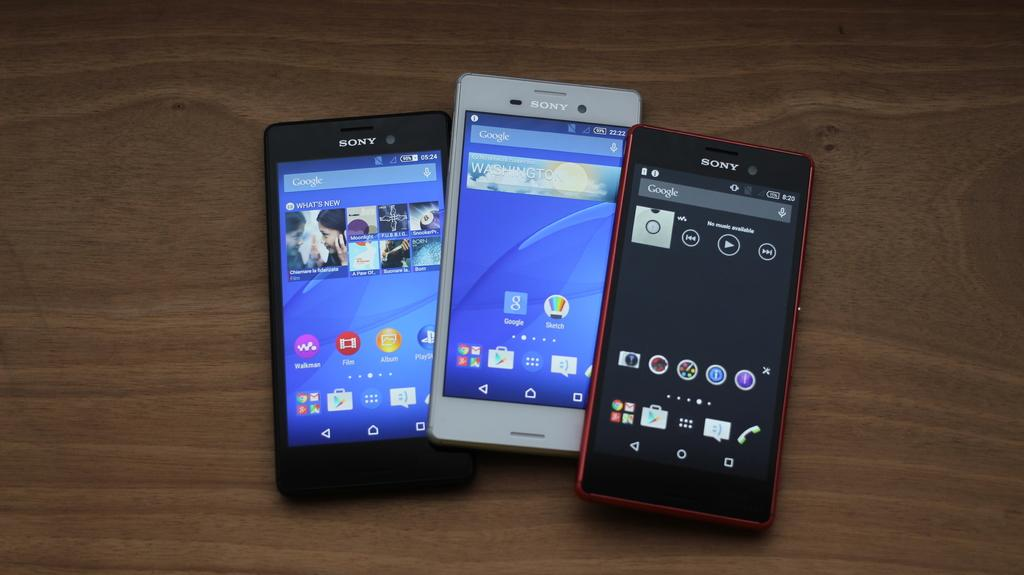<image>
Render a clear and concise summary of the photo. Three cell phones are on a wooden table and they all say Sony on them. 